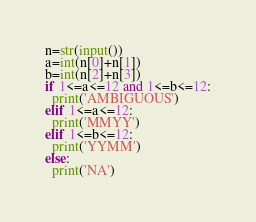<code> <loc_0><loc_0><loc_500><loc_500><_Python_>n=str(input())
a=int(n[0]+n[1])
b=int(n[2]+n[3])
if 1<=a<=12 and 1<=b<=12:
  print('AMBIGUOUS')
elif 1<=a<=12:
  print('MMYY')
elif 1<=b<=12:
  print('YYMM')
else:
  print('NA')</code> 